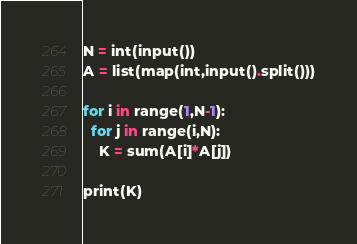Convert code to text. <code><loc_0><loc_0><loc_500><loc_500><_Python_>N = int(input())
A = list(map(int,input().split()))

for i in range(1,N-1):
  for j in range(i,N):
    K = sum(A[i]*A[j])

print(K)</code> 